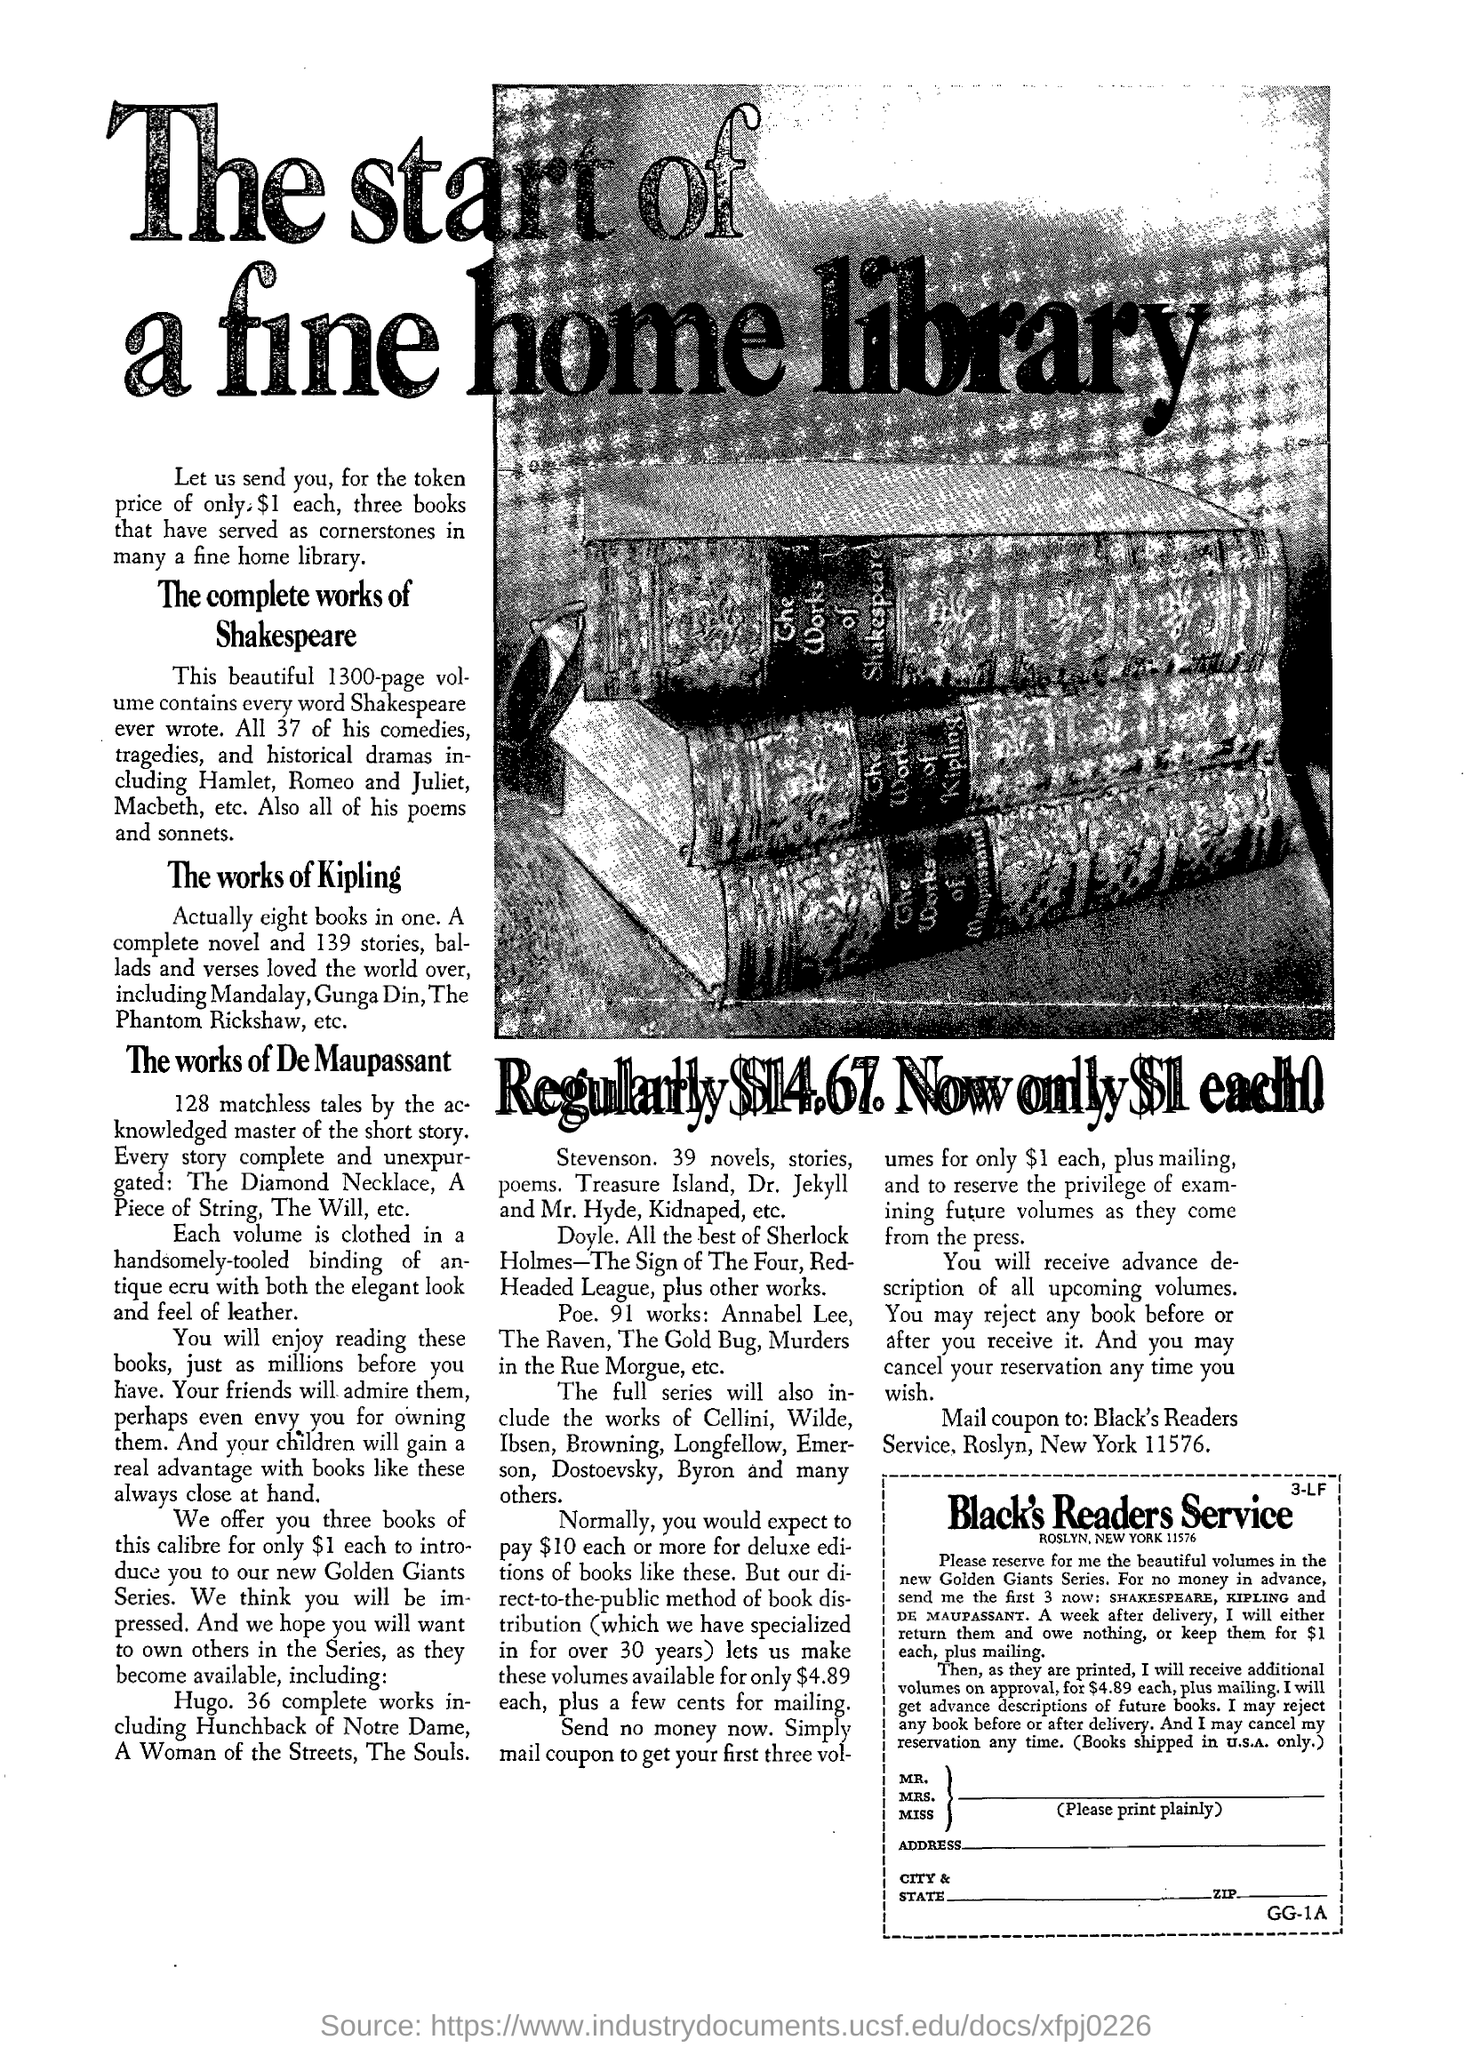Heading of the document?
Your response must be concise. The start of a fine home library. What is the price of the token?
Your answer should be compact. $1 each. How many pages does the volume contain?
Your answer should be compact. 1300. How many stories are present in The works of Kipling?
Your answer should be compact. 139 stories. 